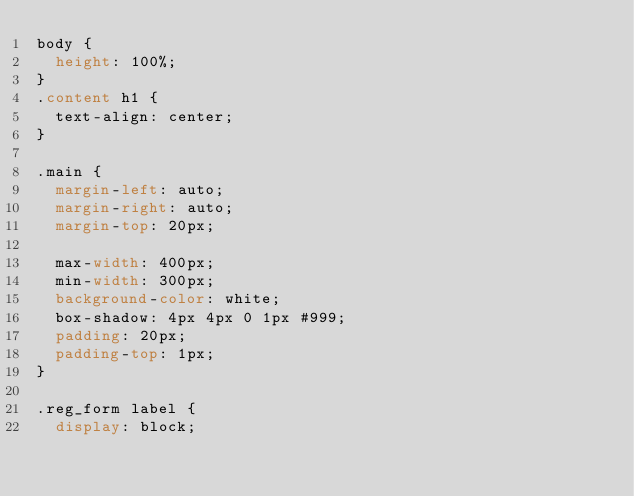<code> <loc_0><loc_0><loc_500><loc_500><_CSS_>body {
  height: 100%;
}
.content h1 {
  text-align: center;
}

.main {
  margin-left: auto;
  margin-right: auto;
  margin-top: 20px;

  max-width: 400px;
  min-width: 300px;
  background-color: white;
  box-shadow: 4px 4px 0 1px #999;
  padding: 20px;
  padding-top: 1px;
}

.reg_form label {
  display: block;</code> 